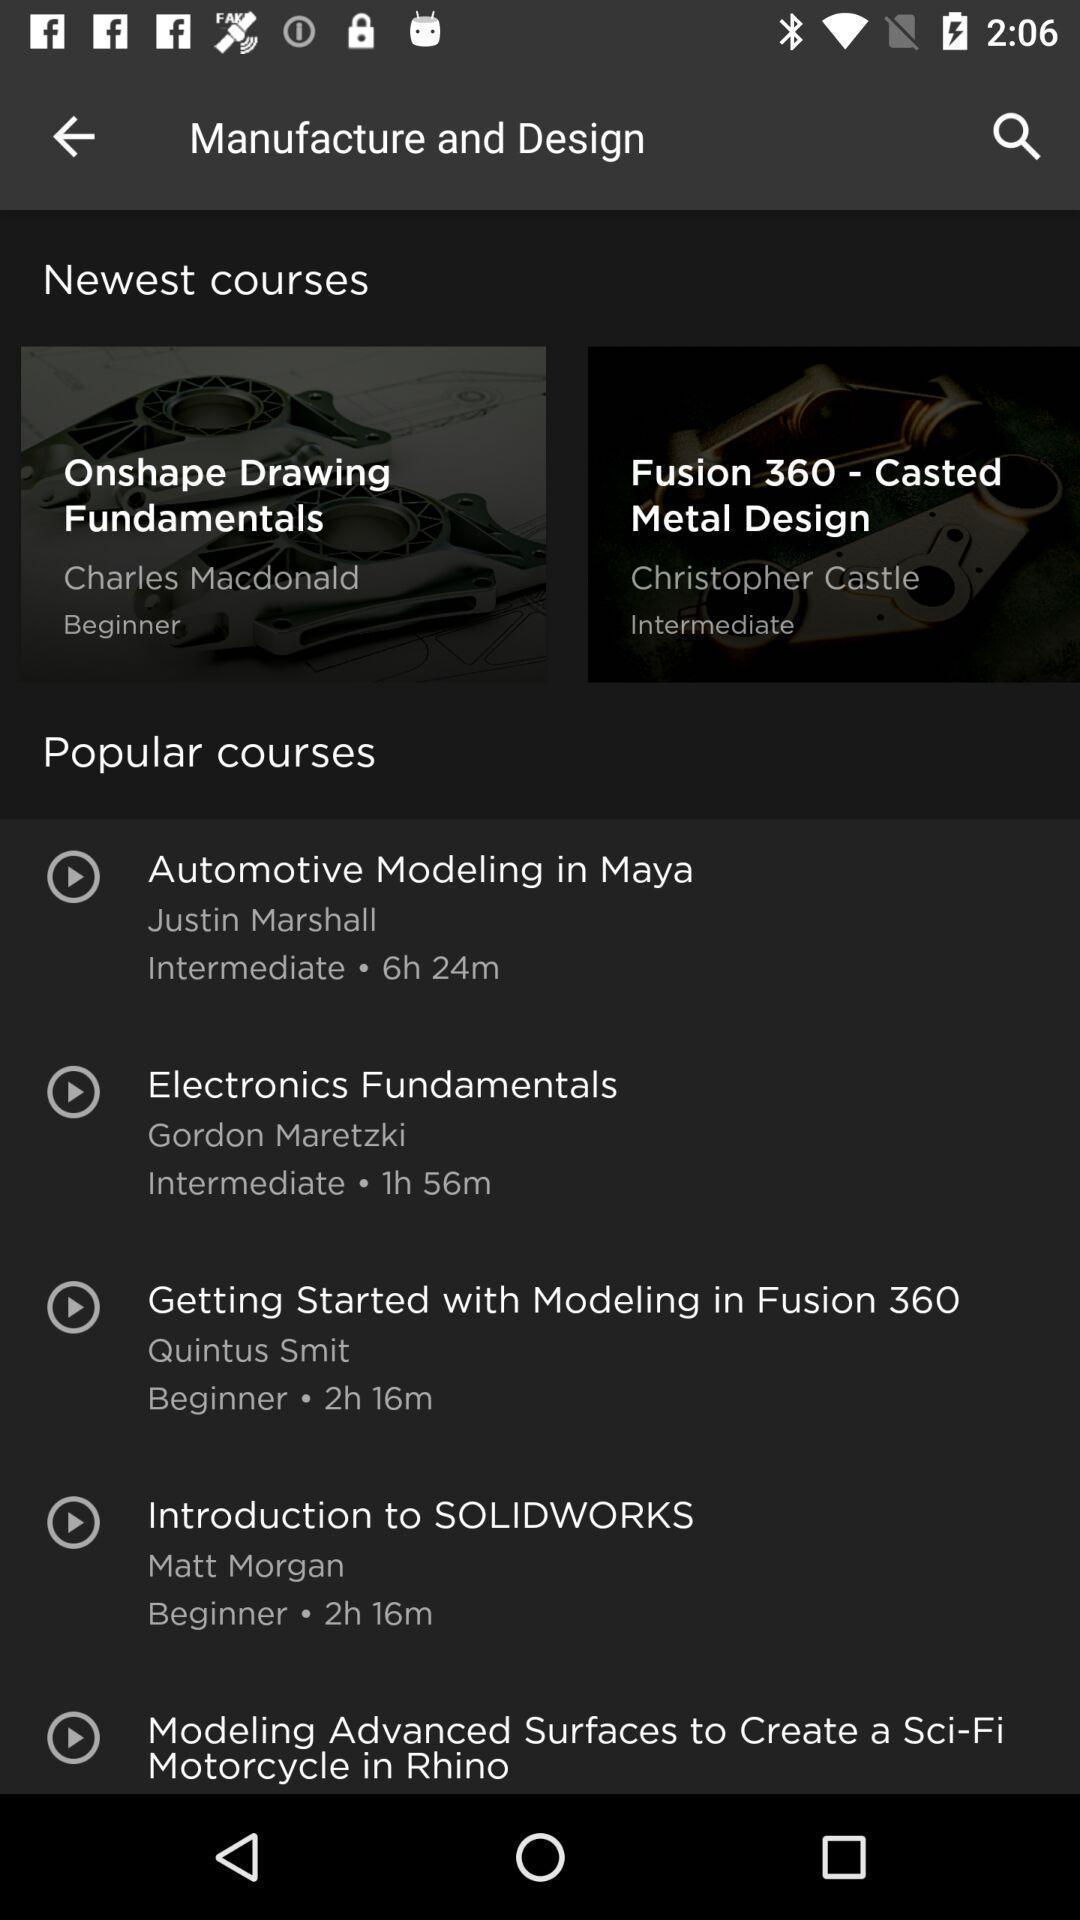Summarize the information in this screenshot. Search page is to find the courses and fundamentals. 